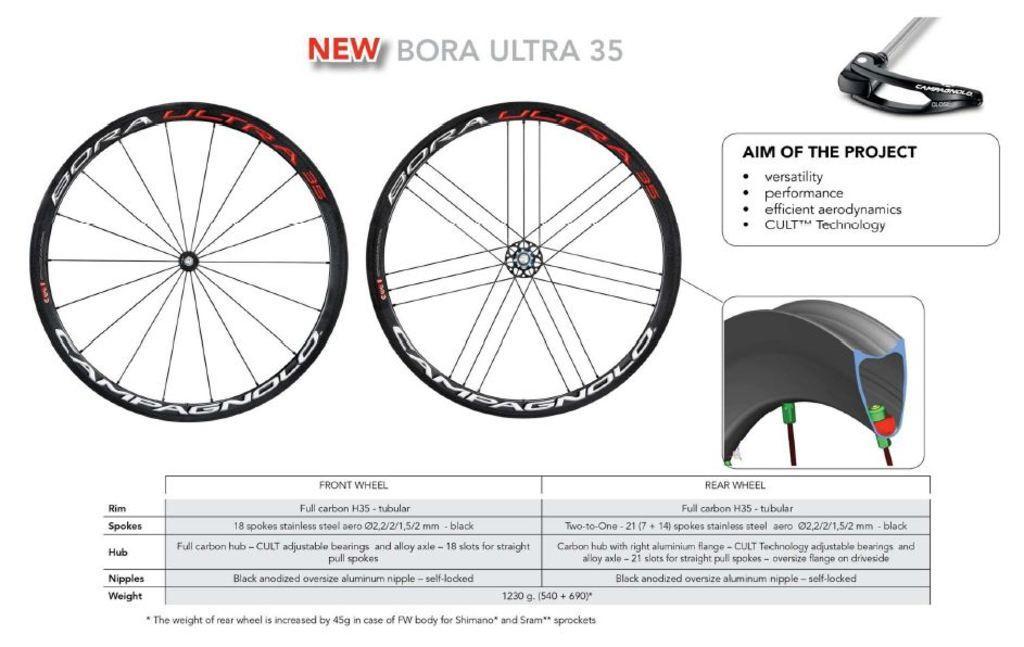In one or two sentences, can you explain what this image depicts? In this image there are pictures and text. In the center of the image there are pictures of wheels. Below the pictures there is text on the image. To the right there are pictures of a few objects. 